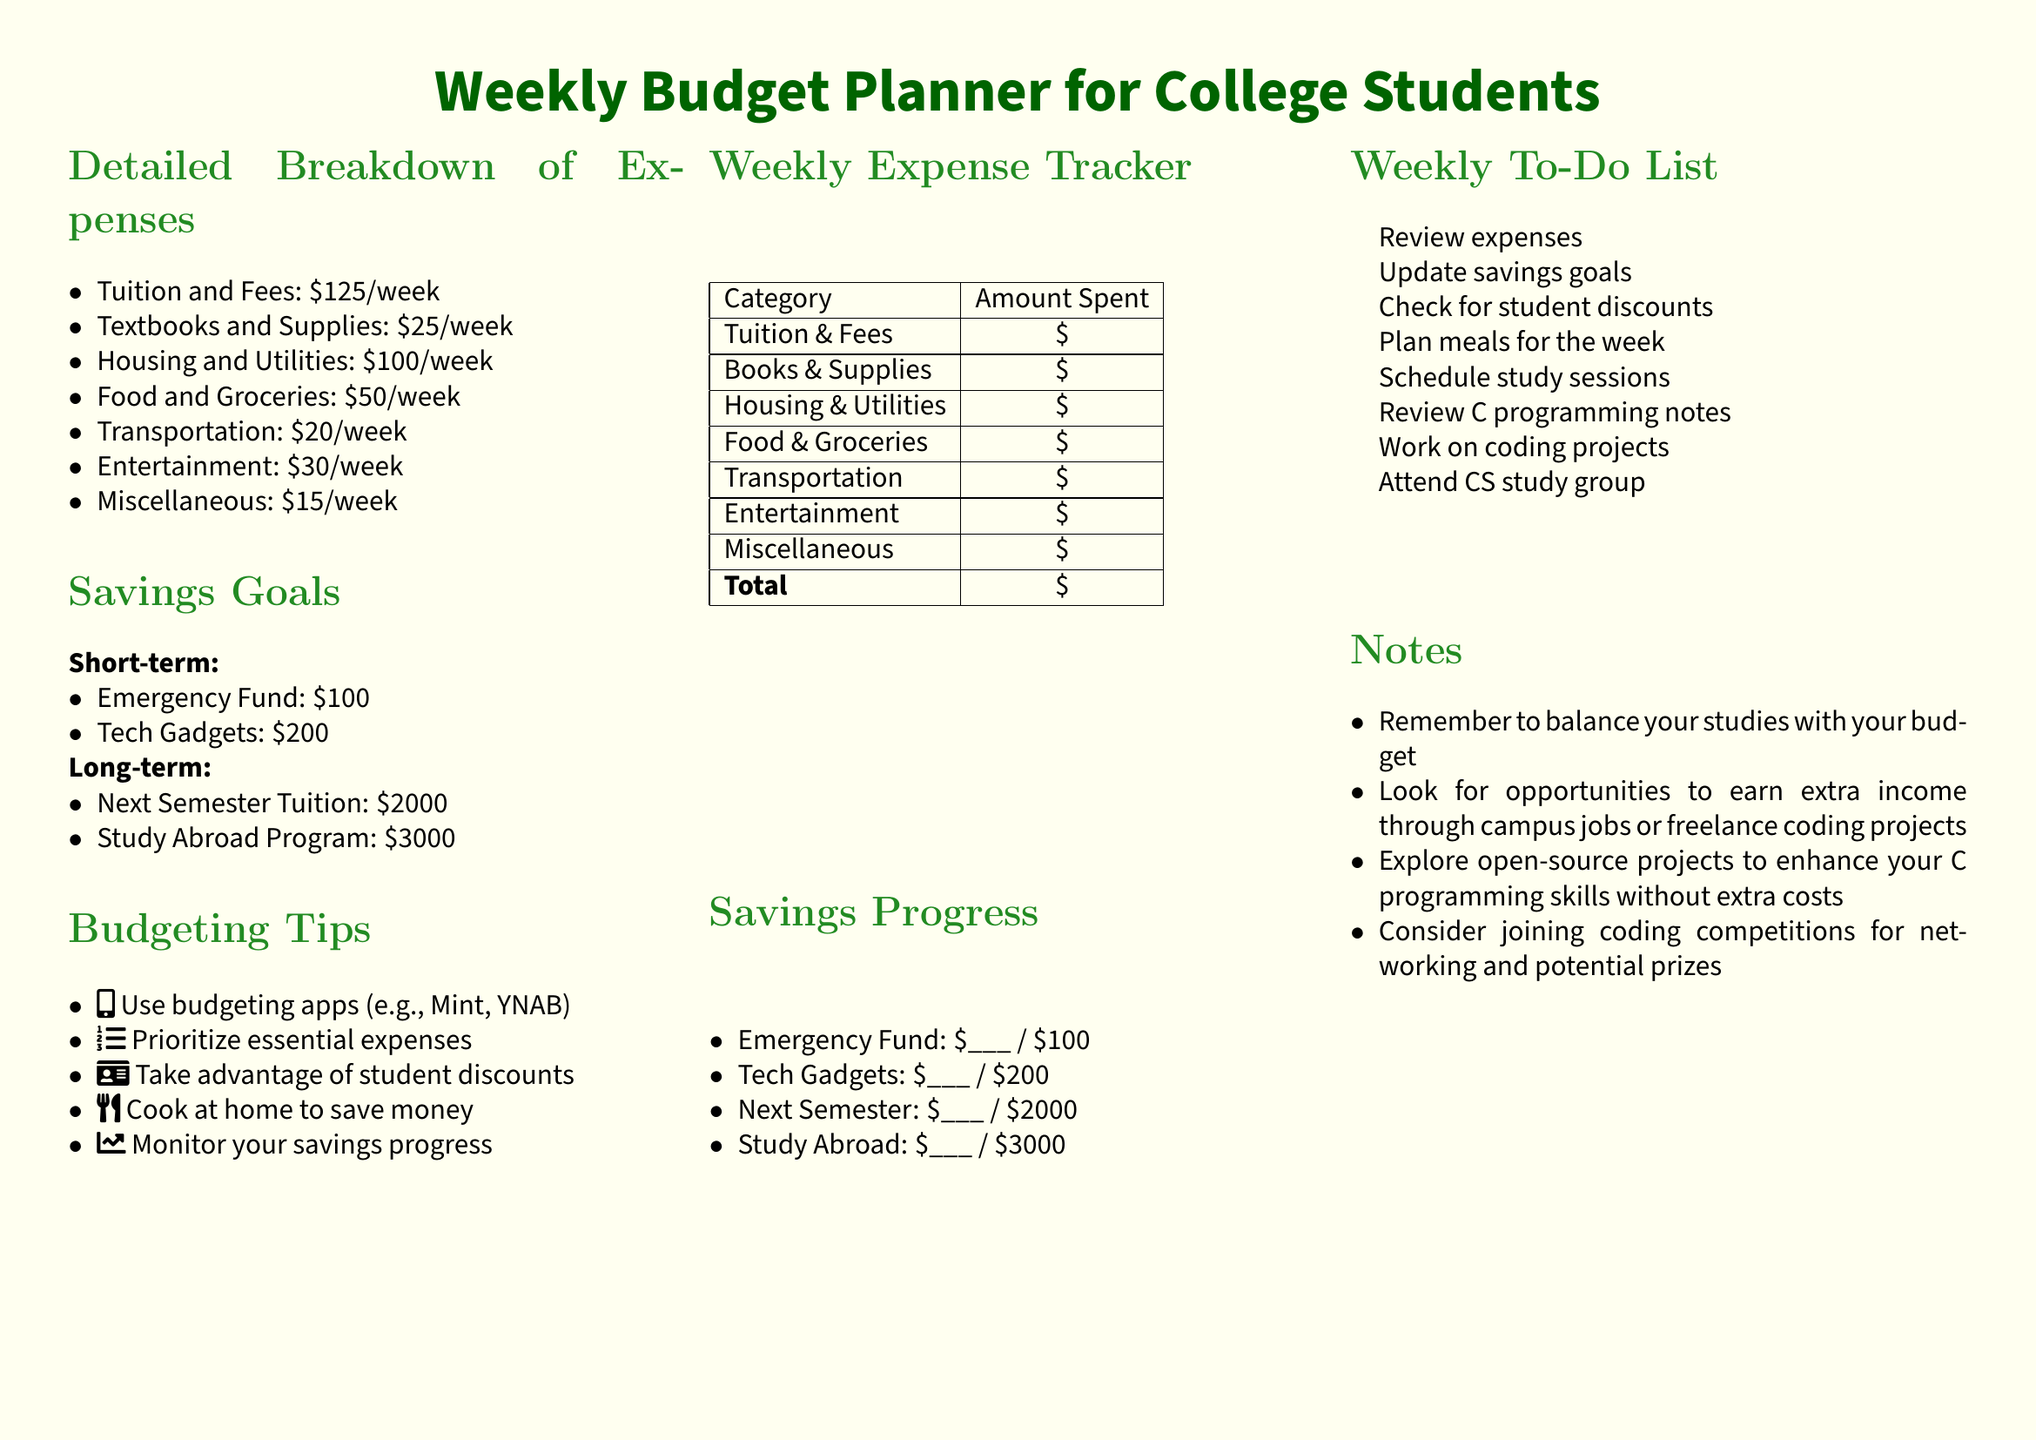What is the total cost of Tuition and Fees per week? The document states that Tuition and Fees cost $125 per week.
Answer: $125 How much is the savings goal for the Emergency Fund? The specified amount for the Emergency Fund is $100.
Answer: $100 What is the weekly expense allocated for Food and Groceries? The document allocates $50 per week for Food and Groceries.
Answer: $50 Which budgeting app is mentioned in the tips? The document mentions apps like Mint and YNAB as budgeting tools.
Answer: Mint, YNAB What is the total savings goal for Study Abroad? The savings goal for the Study Abroad Program is stated as $3000.
Answer: $3000 How many categories are listed under Detailed Breakdown of Expenses? There are seven categories listed for the breakdown of expenses.
Answer: 7 What is one suggested activity for the Weekly To-Do List? The document includes checking for student discounts as a suggested activity.
Answer: Check for student discounts What is the purpose of the Weekly Expense Tracker? The Tracker is intended to help students keep track of their weekly expenditures.
Answer: Track expenses What amount is set aside for Transportation weekly? The document states that $20 is allocated for Transportation each week.
Answer: $20 What is a recommended way to save money on meals? The document suggests cooking at home to save money.
Answer: Cook at home 